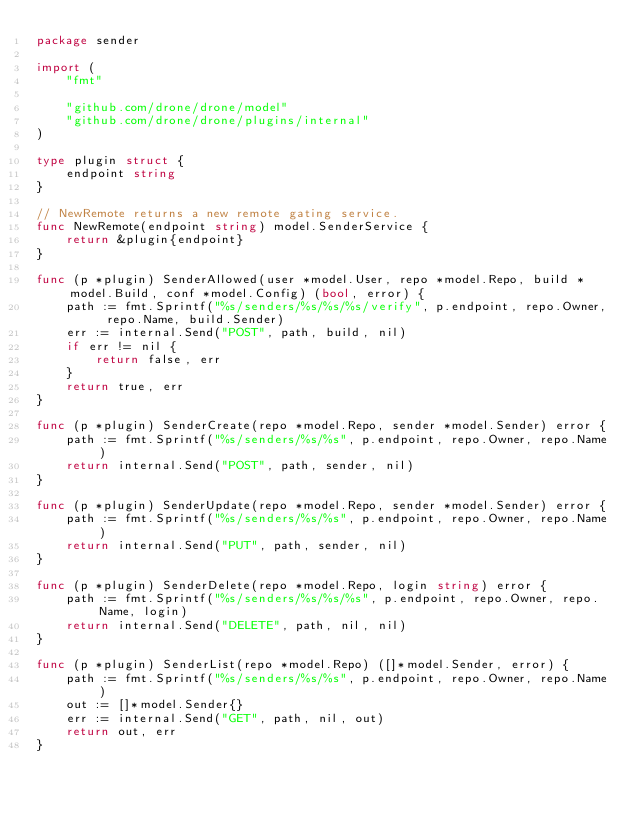Convert code to text. <code><loc_0><loc_0><loc_500><loc_500><_Go_>package sender

import (
	"fmt"

	"github.com/drone/drone/model"
	"github.com/drone/drone/plugins/internal"
)

type plugin struct {
	endpoint string
}

// NewRemote returns a new remote gating service.
func NewRemote(endpoint string) model.SenderService {
	return &plugin{endpoint}
}

func (p *plugin) SenderAllowed(user *model.User, repo *model.Repo, build *model.Build, conf *model.Config) (bool, error) {
	path := fmt.Sprintf("%s/senders/%s/%s/%s/verify", p.endpoint, repo.Owner, repo.Name, build.Sender)
	err := internal.Send("POST", path, build, nil)
	if err != nil {
		return false, err
	}
	return true, err
}

func (p *plugin) SenderCreate(repo *model.Repo, sender *model.Sender) error {
	path := fmt.Sprintf("%s/senders/%s/%s", p.endpoint, repo.Owner, repo.Name)
	return internal.Send("POST", path, sender, nil)
}

func (p *plugin) SenderUpdate(repo *model.Repo, sender *model.Sender) error {
	path := fmt.Sprintf("%s/senders/%s/%s", p.endpoint, repo.Owner, repo.Name)
	return internal.Send("PUT", path, sender, nil)
}

func (p *plugin) SenderDelete(repo *model.Repo, login string) error {
	path := fmt.Sprintf("%s/senders/%s/%s/%s", p.endpoint, repo.Owner, repo.Name, login)
	return internal.Send("DELETE", path, nil, nil)
}

func (p *plugin) SenderList(repo *model.Repo) ([]*model.Sender, error) {
	path := fmt.Sprintf("%s/senders/%s/%s", p.endpoint, repo.Owner, repo.Name)
	out := []*model.Sender{}
	err := internal.Send("GET", path, nil, out)
	return out, err
}
</code> 